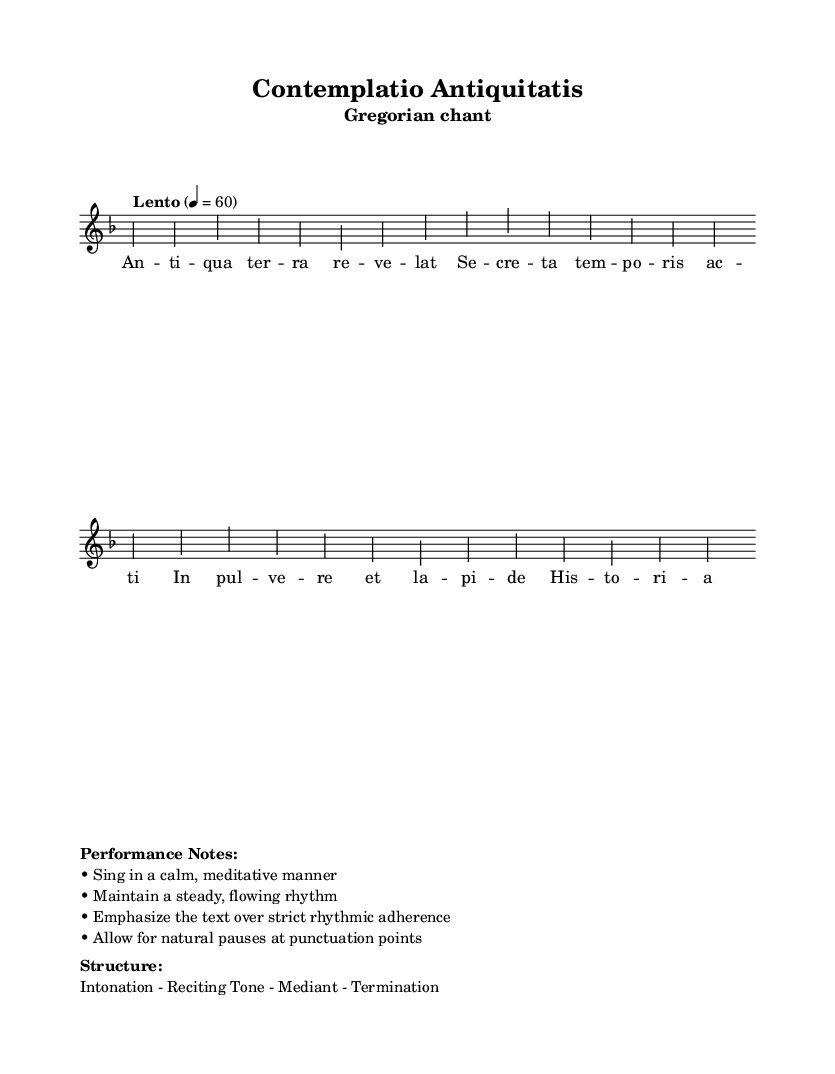What is the key signature of this music? The key signature is indicated by the symbol shown at the beginning of the staff, which is D minor. This is represented by one flat (B flat).
Answer: D minor What is the time signature of this music? The time signature is located right after the key signature and includes the numbers indicating beats per measure, which is 4/4. This means there are 4 beats in each measure.
Answer: 4/4 What tempo marking is given? The tempo marking is indicated in Italian terms at the beginning of the score, which specifies the speed of the piece as "Lento," meaning slow. The numerical value of 60 suggests a steady pace of 60 beats per minute.
Answer: Lento What is the overall theme of the text contained in the music? The lyrics convey a sense of reverence and contemplation about the secrets of time and history, reflecting themes typical of religious chants meant for meditation.
Answer: Contemplation What is the form structure used in this Gregorian chant? The structure is indicated in the markup section, where it outlines the sections of the chant as Intonation, Reciting Tone, Mediant, and Termination, which is a traditional format for such music.
Answer: Intonation - Reciting Tone - Mediant - Termination How should the performance style be characterized? Performance notes describe the style preferences for singing, emphasizing a calm and meditative approach, which indicates that it should be expressive rather than strictly rhythmic.
Answer: Meditative 